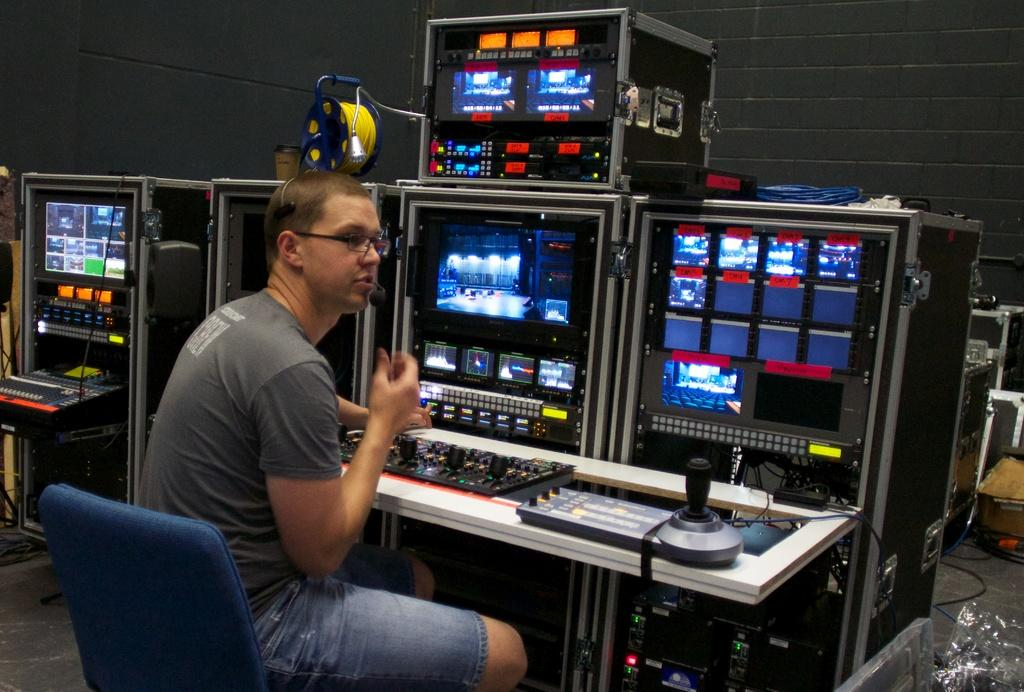What is the person in the image doing? The person is sitting on a chair and using editing equipment. What can be seen in the background of the image? There is a wall in the background of the image. What news is the queen announcing to the giants in the image? There is no queen or giants present in the image, and therefore no such news announcement can be observed. 